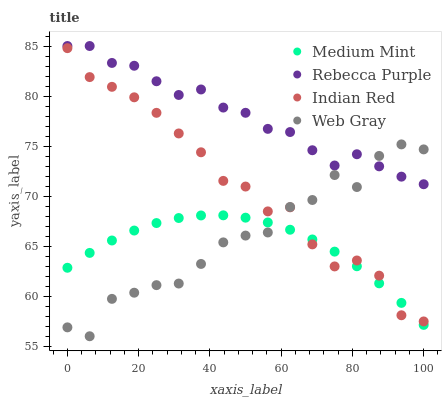Does Medium Mint have the minimum area under the curve?
Answer yes or no. Yes. Does Rebecca Purple have the maximum area under the curve?
Answer yes or no. Yes. Does Web Gray have the minimum area under the curve?
Answer yes or no. No. Does Web Gray have the maximum area under the curve?
Answer yes or no. No. Is Medium Mint the smoothest?
Answer yes or no. Yes. Is Web Gray the roughest?
Answer yes or no. Yes. Is Rebecca Purple the smoothest?
Answer yes or no. No. Is Rebecca Purple the roughest?
Answer yes or no. No. Does Web Gray have the lowest value?
Answer yes or no. Yes. Does Rebecca Purple have the lowest value?
Answer yes or no. No. Does Rebecca Purple have the highest value?
Answer yes or no. Yes. Does Web Gray have the highest value?
Answer yes or no. No. Is Medium Mint less than Rebecca Purple?
Answer yes or no. Yes. Is Rebecca Purple greater than Indian Red?
Answer yes or no. Yes. Does Web Gray intersect Medium Mint?
Answer yes or no. Yes. Is Web Gray less than Medium Mint?
Answer yes or no. No. Is Web Gray greater than Medium Mint?
Answer yes or no. No. Does Medium Mint intersect Rebecca Purple?
Answer yes or no. No. 